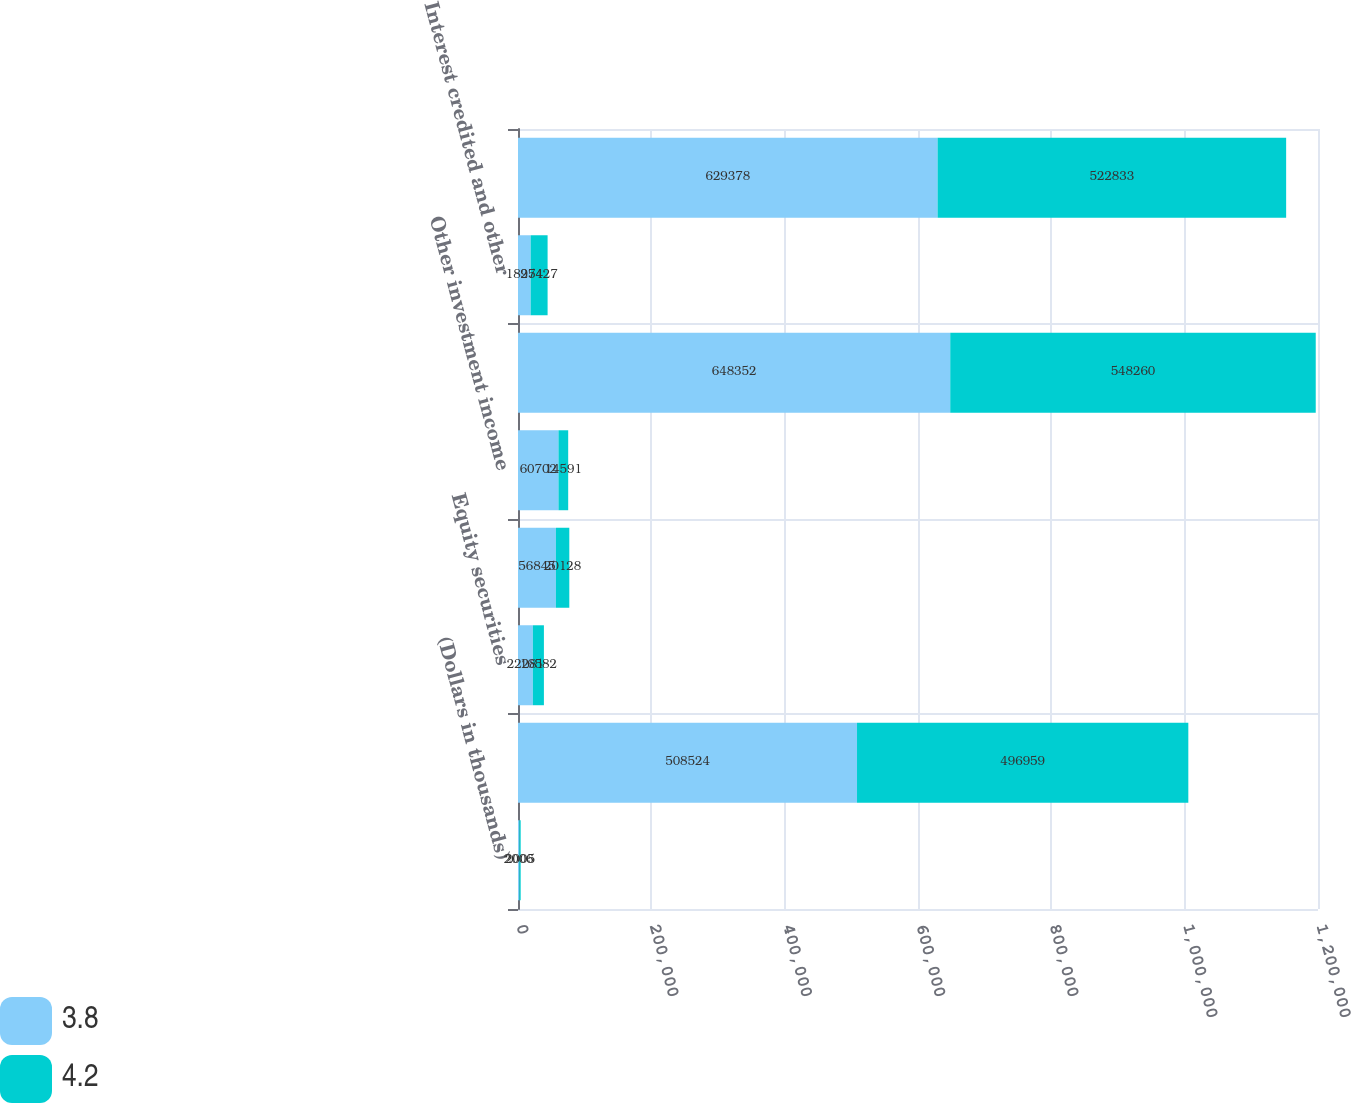<chart> <loc_0><loc_0><loc_500><loc_500><stacked_bar_chart><ecel><fcel>(Dollars in thousands)<fcel>Fixed maturities<fcel>Equity securities<fcel>Short-term investments<fcel>Other investment income<fcel>Total gross investment income<fcel>Interest credited and other<fcel>Total net investment income<nl><fcel>3.8<fcel>2006<fcel>508524<fcel>22281<fcel>56845<fcel>60702<fcel>648352<fcel>18974<fcel>629378<nl><fcel>4.2<fcel>2005<fcel>496959<fcel>16582<fcel>20128<fcel>14591<fcel>548260<fcel>25427<fcel>522833<nl></chart> 